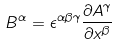Convert formula to latex. <formula><loc_0><loc_0><loc_500><loc_500>B ^ { \alpha } = \epsilon ^ { \alpha \beta \gamma } \frac { \partial A ^ { \gamma } } { \partial x ^ { \beta } }</formula> 